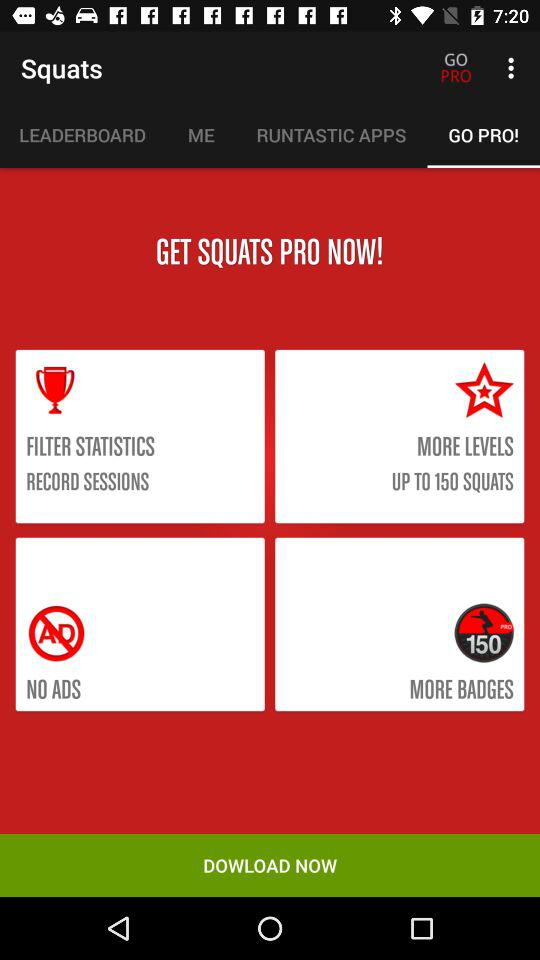How many squats have been completed?
When the provided information is insufficient, respond with <no answer>. <no answer> 